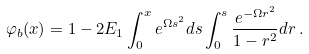<formula> <loc_0><loc_0><loc_500><loc_500>\varphi _ { b } ( x ) = 1 - 2 E _ { 1 } \int _ { 0 } ^ { x } e ^ { \Omega s ^ { 2 } } d s \int _ { 0 } ^ { s } \frac { e ^ { - \Omega r ^ { 2 } } } { 1 - r ^ { 2 } } d r \, .</formula> 